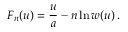<formula> <loc_0><loc_0><loc_500><loc_500>F _ { n } ( u ) = { \frac { u } { a } } - n \ln w ( u ) \, .</formula> 